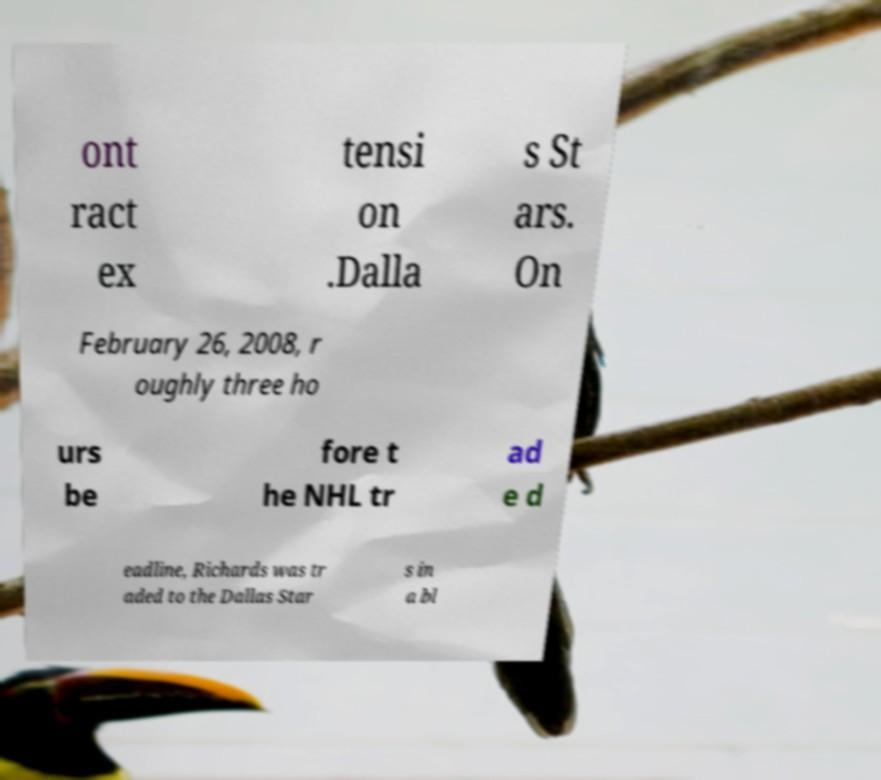Can you read and provide the text displayed in the image?This photo seems to have some interesting text. Can you extract and type it out for me? ont ract ex tensi on .Dalla s St ars. On February 26, 2008, r oughly three ho urs be fore t he NHL tr ad e d eadline, Richards was tr aded to the Dallas Star s in a bl 